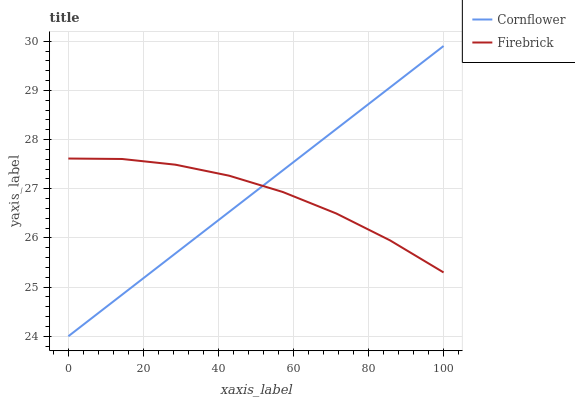Does Firebrick have the minimum area under the curve?
Answer yes or no. Yes. Does Cornflower have the maximum area under the curve?
Answer yes or no. Yes. Does Firebrick have the maximum area under the curve?
Answer yes or no. No. Is Cornflower the smoothest?
Answer yes or no. Yes. Is Firebrick the roughest?
Answer yes or no. Yes. Is Firebrick the smoothest?
Answer yes or no. No. Does Cornflower have the lowest value?
Answer yes or no. Yes. Does Firebrick have the lowest value?
Answer yes or no. No. Does Cornflower have the highest value?
Answer yes or no. Yes. Does Firebrick have the highest value?
Answer yes or no. No. Does Firebrick intersect Cornflower?
Answer yes or no. Yes. Is Firebrick less than Cornflower?
Answer yes or no. No. Is Firebrick greater than Cornflower?
Answer yes or no. No. 